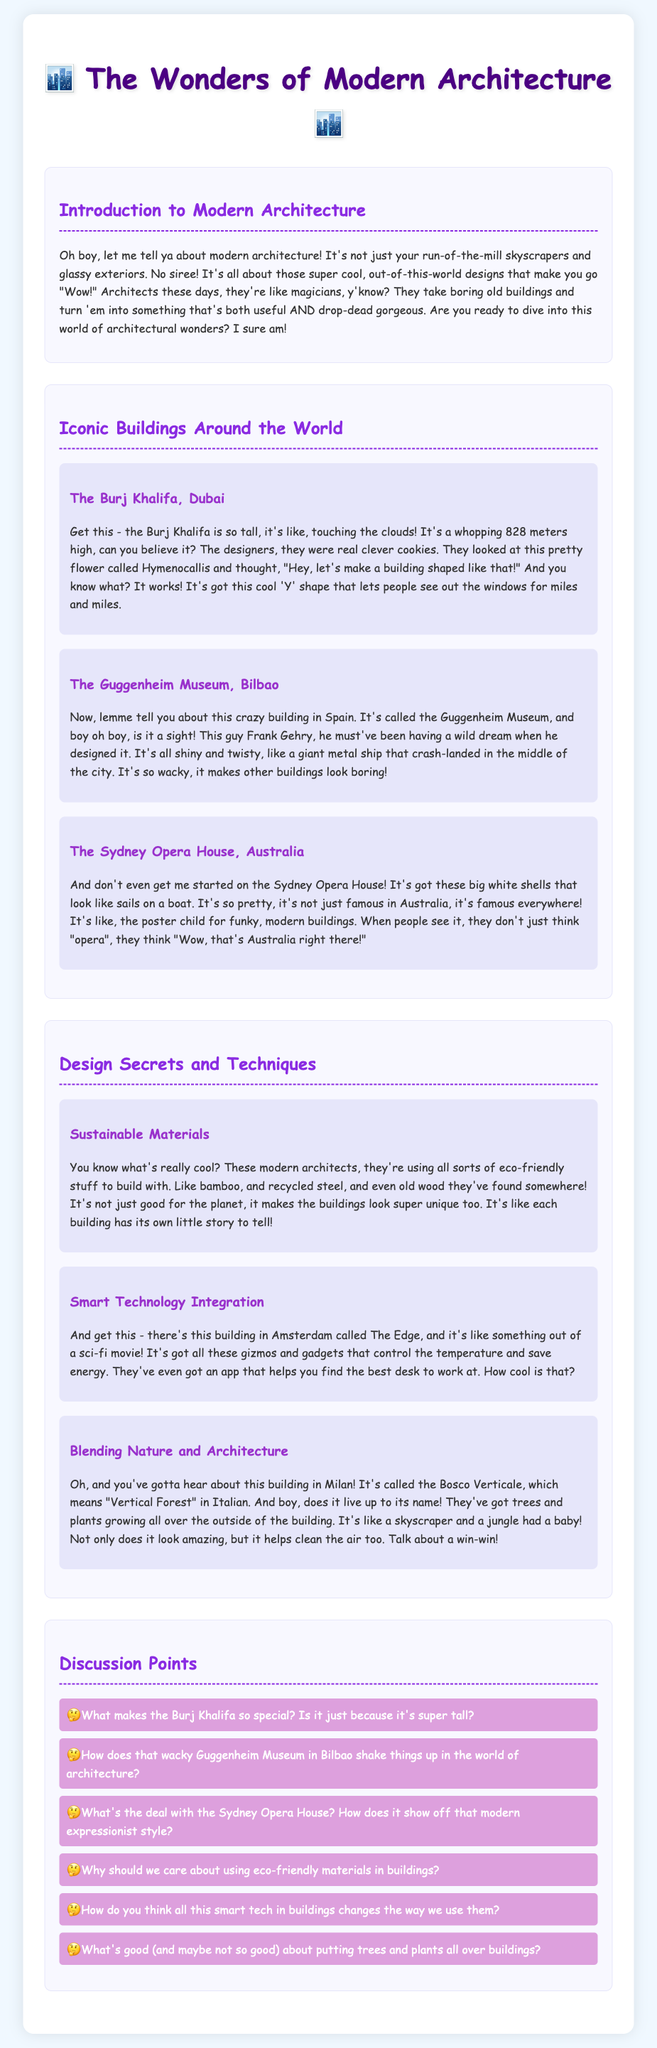What is the height of the Burj Khalifa? The Burj Khalifa is noted to be a whopping 828 meters high in the document.
Answer: 828 meters Who designed the Guggenheim Museum? The document mentions Frank Gehry as the designer of the Guggenheim Museum in Bilbao.
Answer: Frank Gehry What are the shells of the Sydney Opera House likened to? The document expresses that the big white shells of the Sydney Opera House look like sails on a boat.
Answer: Sails on a boat What eco-friendly material is mentioned for use in modern architecture? The document specifically references bamboo as an eco-friendly material being used by modern architects.
Answer: Bamboo What is the name of the building in Amsterdam with smart technology? The document refers to The Edge as the building in Amsterdam featuring smart technology integration.
Answer: The Edge What does Bosco Verticale mean in Italian? The document explains that Bosco Verticale translates to "Vertical Forest" in Italian.
Answer: Vertical Forest How does the design of the Guggenheim Museum impact architecture? The document indicates that the Guggenheim Museum is seen as wacky, making other buildings look boring.
Answer: It makes other buildings look boring Why is sustainable architecture beneficial according to the document? The document states that using sustainable materials is good for the planet and makes buildings look unique.
Answer: Good for the planet What is the main benefit of blending nature and architecture? The document suggests that blending nature with architecture helps clean the air.
Answer: Helps clean the air 